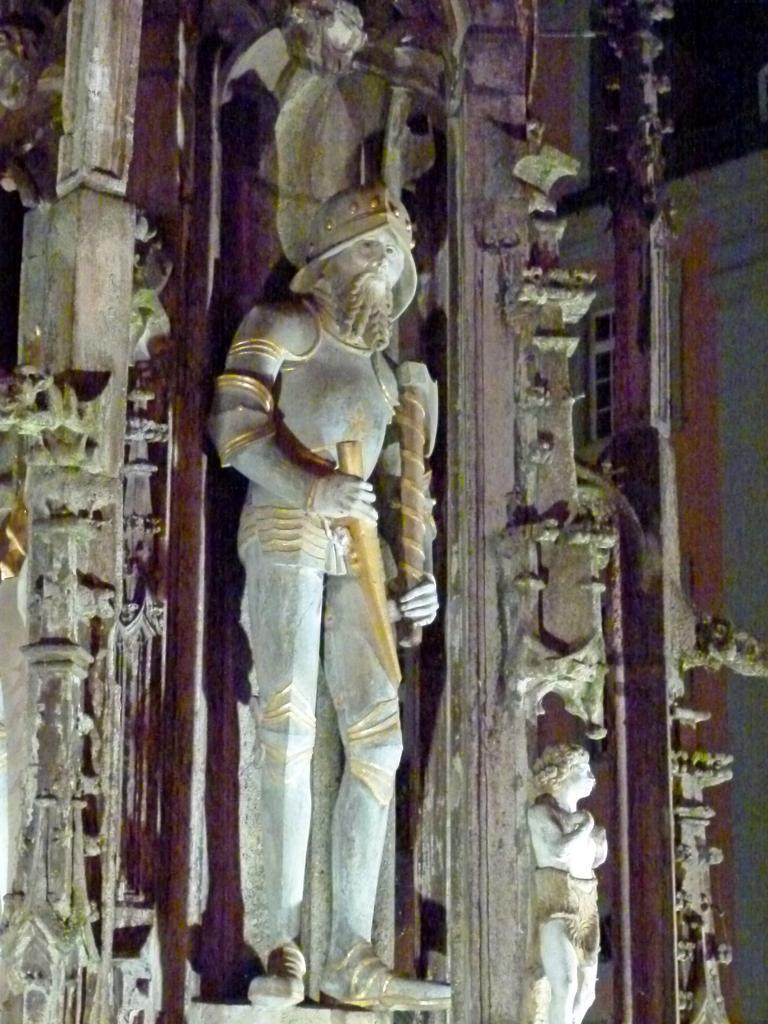Please provide a concise description of this image. In this image I can see the person statue and few pillars. In the background I can see the building. 